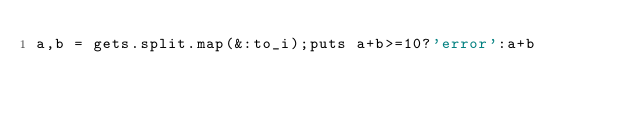Convert code to text. <code><loc_0><loc_0><loc_500><loc_500><_Ruby_>a,b = gets.split.map(&:to_i);puts a+b>=10?'error':a+b</code> 